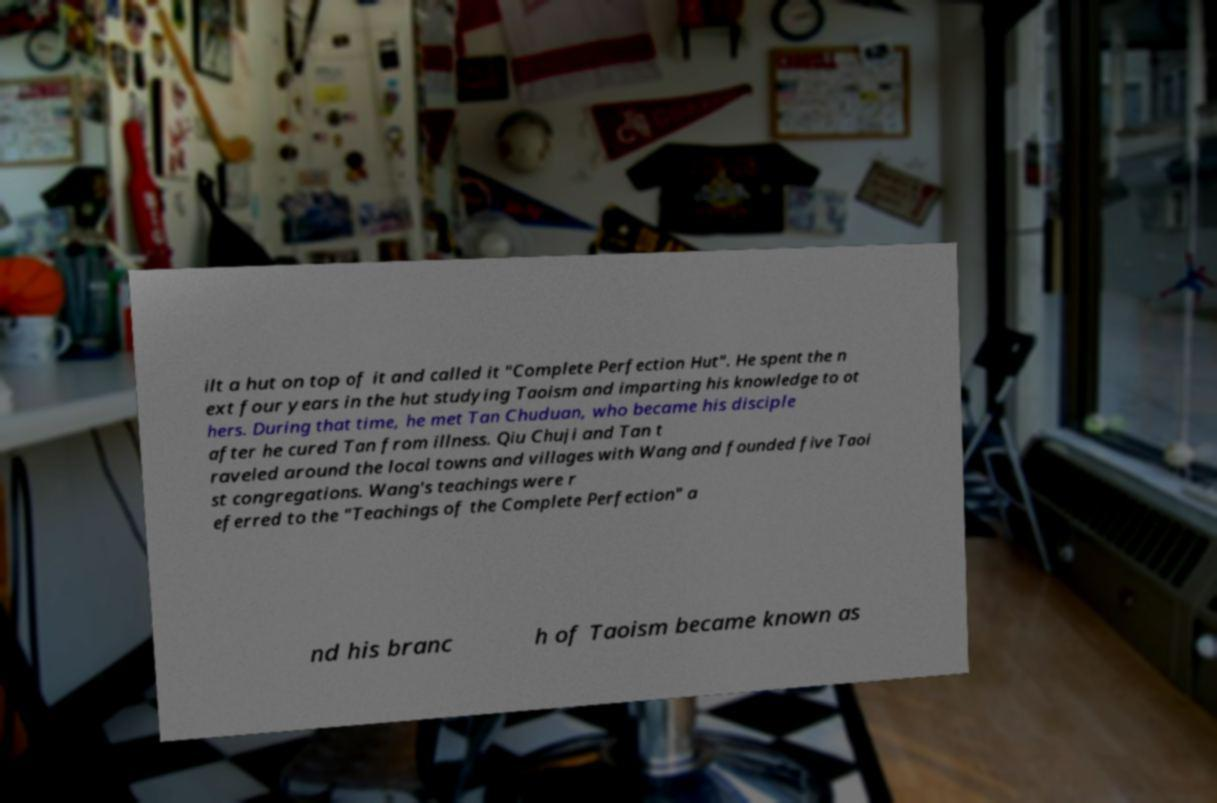Could you assist in decoding the text presented in this image and type it out clearly? ilt a hut on top of it and called it "Complete Perfection Hut". He spent the n ext four years in the hut studying Taoism and imparting his knowledge to ot hers. During that time, he met Tan Chuduan, who became his disciple after he cured Tan from illness. Qiu Chuji and Tan t raveled around the local towns and villages with Wang and founded five Taoi st congregations. Wang's teachings were r eferred to the "Teachings of the Complete Perfection" a nd his branc h of Taoism became known as 